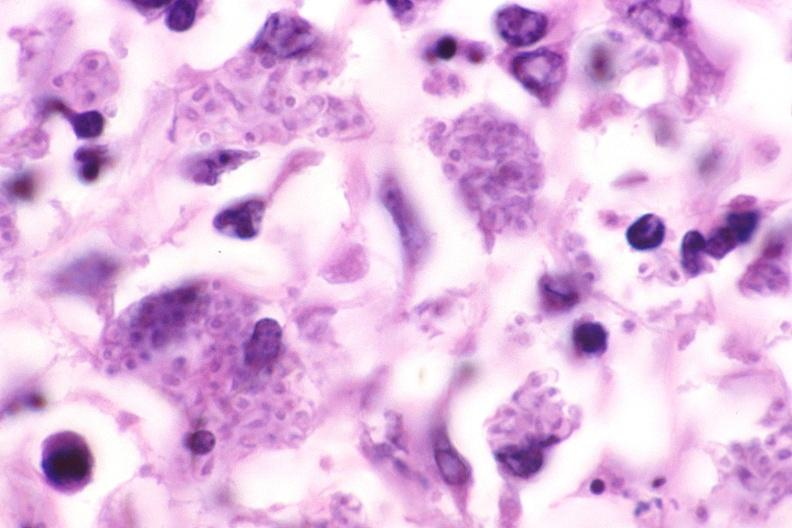what is present?
Answer the question using a single word or phrase. Respiratory 